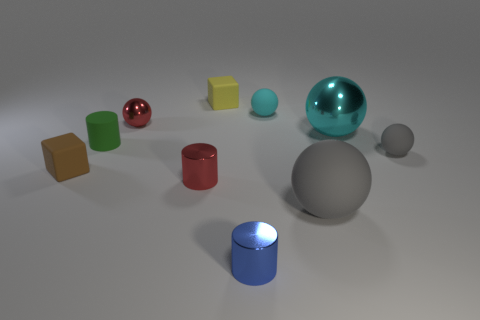Does the big cyan thing have the same shape as the small cyan matte thing?
Your answer should be very brief. Yes. What number of objects are shiny cylinders to the right of the small yellow thing or small matte spheres?
Ensure brevity in your answer.  3. What shape is the tiny gray object that is in front of the matte cube that is behind the shiny sphere on the left side of the tiny cyan matte sphere?
Ensure brevity in your answer.  Sphere. What is the shape of the small yellow thing that is made of the same material as the tiny brown block?
Ensure brevity in your answer.  Cube. The yellow matte object is what size?
Your answer should be very brief. Small. Is the size of the red sphere the same as the green matte cylinder?
Ensure brevity in your answer.  Yes. How many objects are things that are to the left of the small metallic sphere or tiny objects that are on the left side of the blue metallic cylinder?
Offer a terse response. 5. There is a small matte cube that is in front of the metal sphere that is to the left of the big cyan ball; how many tiny red spheres are left of it?
Provide a short and direct response. 0. What size is the red object behind the brown rubber cube?
Make the answer very short. Small. How many gray shiny spheres are the same size as the yellow object?
Your answer should be very brief. 0. 